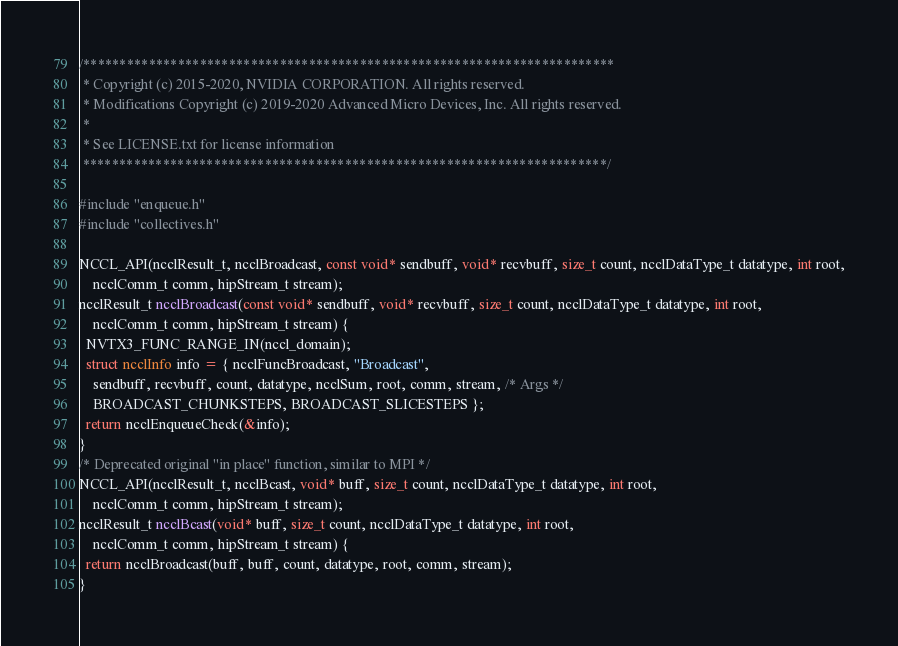Convert code to text. <code><loc_0><loc_0><loc_500><loc_500><_C++_>/*************************************************************************
 * Copyright (c) 2015-2020, NVIDIA CORPORATION. All rights reserved.
 * Modifications Copyright (c) 2019-2020 Advanced Micro Devices, Inc. All rights reserved.
 *
 * See LICENSE.txt for license information
 ************************************************************************/

#include "enqueue.h"
#include "collectives.h"

NCCL_API(ncclResult_t, ncclBroadcast, const void* sendbuff, void* recvbuff, size_t count, ncclDataType_t datatype, int root,
    ncclComm_t comm, hipStream_t stream);
ncclResult_t ncclBroadcast(const void* sendbuff, void* recvbuff, size_t count, ncclDataType_t datatype, int root,
    ncclComm_t comm, hipStream_t stream) {
  NVTX3_FUNC_RANGE_IN(nccl_domain);
  struct ncclInfo info = { ncclFuncBroadcast, "Broadcast",
    sendbuff, recvbuff, count, datatype, ncclSum, root, comm, stream, /* Args */
    BROADCAST_CHUNKSTEPS, BROADCAST_SLICESTEPS };
  return ncclEnqueueCheck(&info);
}
/* Deprecated original "in place" function, similar to MPI */
NCCL_API(ncclResult_t, ncclBcast, void* buff, size_t count, ncclDataType_t datatype, int root,
    ncclComm_t comm, hipStream_t stream);
ncclResult_t ncclBcast(void* buff, size_t count, ncclDataType_t datatype, int root,
    ncclComm_t comm, hipStream_t stream) {
  return ncclBroadcast(buff, buff, count, datatype, root, comm, stream);
}

</code> 